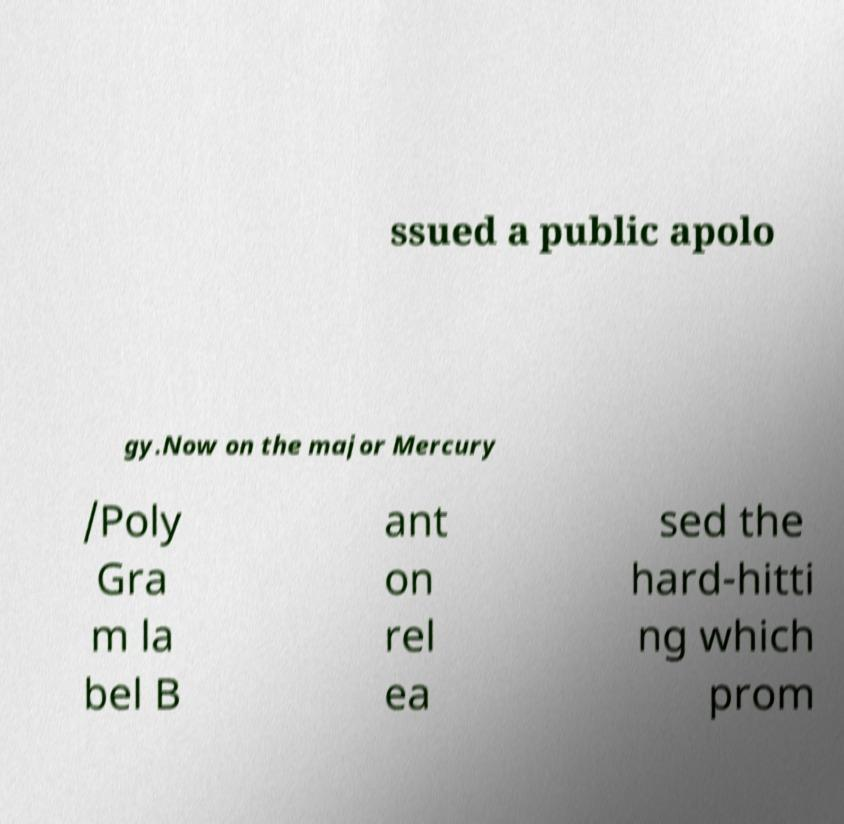There's text embedded in this image that I need extracted. Can you transcribe it verbatim? ssued a public apolo gy.Now on the major Mercury /Poly Gra m la bel B ant on rel ea sed the hard-hitti ng which prom 